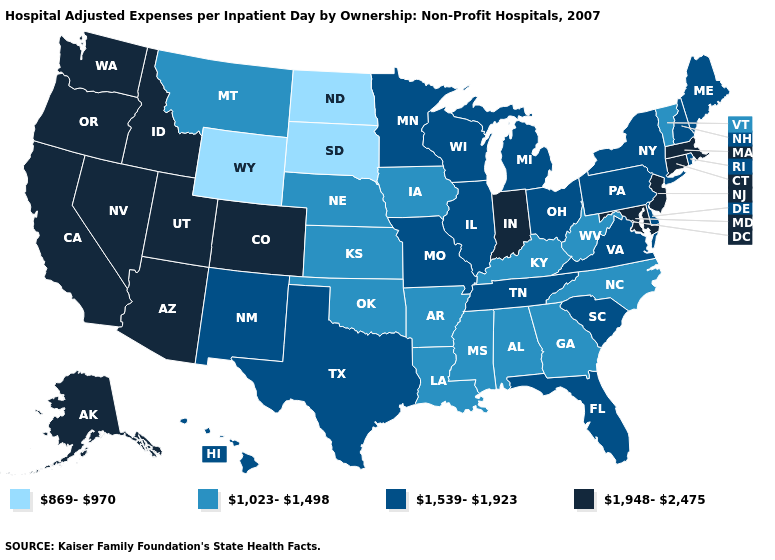Does the first symbol in the legend represent the smallest category?
Give a very brief answer. Yes. Which states hav the highest value in the South?
Answer briefly. Maryland. What is the value of New Jersey?
Quick response, please. 1,948-2,475. Name the states that have a value in the range 869-970?
Keep it brief. North Dakota, South Dakota, Wyoming. Does the first symbol in the legend represent the smallest category?
Keep it brief. Yes. What is the highest value in states that border Massachusetts?
Concise answer only. 1,948-2,475. Which states have the lowest value in the USA?
Concise answer only. North Dakota, South Dakota, Wyoming. Name the states that have a value in the range 1,539-1,923?
Concise answer only. Delaware, Florida, Hawaii, Illinois, Maine, Michigan, Minnesota, Missouri, New Hampshire, New Mexico, New York, Ohio, Pennsylvania, Rhode Island, South Carolina, Tennessee, Texas, Virginia, Wisconsin. Among the states that border Oklahoma , does Missouri have the lowest value?
Answer briefly. No. Among the states that border Minnesota , does Wisconsin have the highest value?
Answer briefly. Yes. Name the states that have a value in the range 1,539-1,923?
Concise answer only. Delaware, Florida, Hawaii, Illinois, Maine, Michigan, Minnesota, Missouri, New Hampshire, New Mexico, New York, Ohio, Pennsylvania, Rhode Island, South Carolina, Tennessee, Texas, Virginia, Wisconsin. Name the states that have a value in the range 1,948-2,475?
Short answer required. Alaska, Arizona, California, Colorado, Connecticut, Idaho, Indiana, Maryland, Massachusetts, Nevada, New Jersey, Oregon, Utah, Washington. Does Massachusetts have the highest value in the USA?
Keep it brief. Yes. 